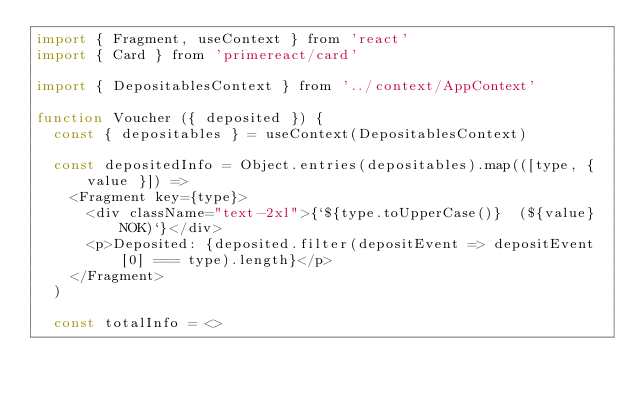<code> <loc_0><loc_0><loc_500><loc_500><_JavaScript_>import { Fragment, useContext } from 'react'
import { Card } from 'primereact/card'

import { DepositablesContext } from '../context/AppContext'

function Voucher ({ deposited }) {
  const { depositables } = useContext(DepositablesContext)

  const depositedInfo = Object.entries(depositables).map(([type, { value }]) =>
    <Fragment key={type}>
      <div className="text-2xl">{`${type.toUpperCase()}  (${value} NOK)`}</div>
      <p>Deposited: {deposited.filter(depositEvent => depositEvent[0] === type).length}</p>
    </Fragment>
  )

  const totalInfo = <></code> 